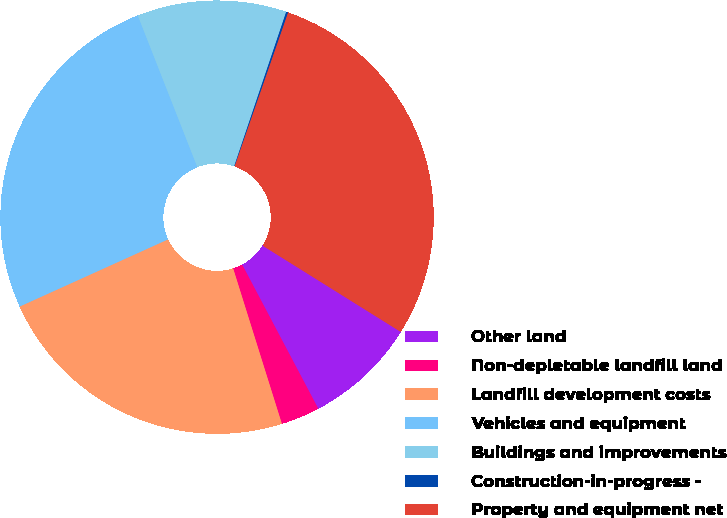Convert chart to OTSL. <chart><loc_0><loc_0><loc_500><loc_500><pie_chart><fcel>Other land<fcel>Non-depletable landfill land<fcel>Landfill development costs<fcel>Vehicles and equipment<fcel>Buildings and improvements<fcel>Construction-in-progress -<fcel>Property and equipment net<nl><fcel>8.38%<fcel>2.9%<fcel>23.07%<fcel>25.81%<fcel>11.13%<fcel>0.15%<fcel>28.56%<nl></chart> 